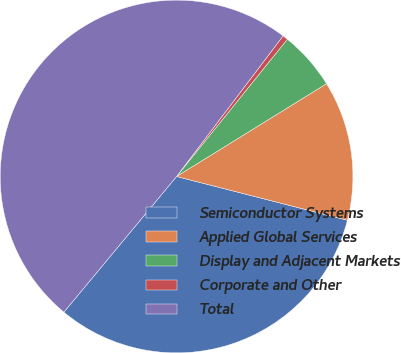Convert chart. <chart><loc_0><loc_0><loc_500><loc_500><pie_chart><fcel>Semiconductor Systems<fcel>Applied Global Services<fcel>Display and Adjacent Markets<fcel>Corporate and Other<fcel>Total<nl><fcel>32.04%<fcel>12.81%<fcel>5.37%<fcel>0.49%<fcel>49.29%<nl></chart> 